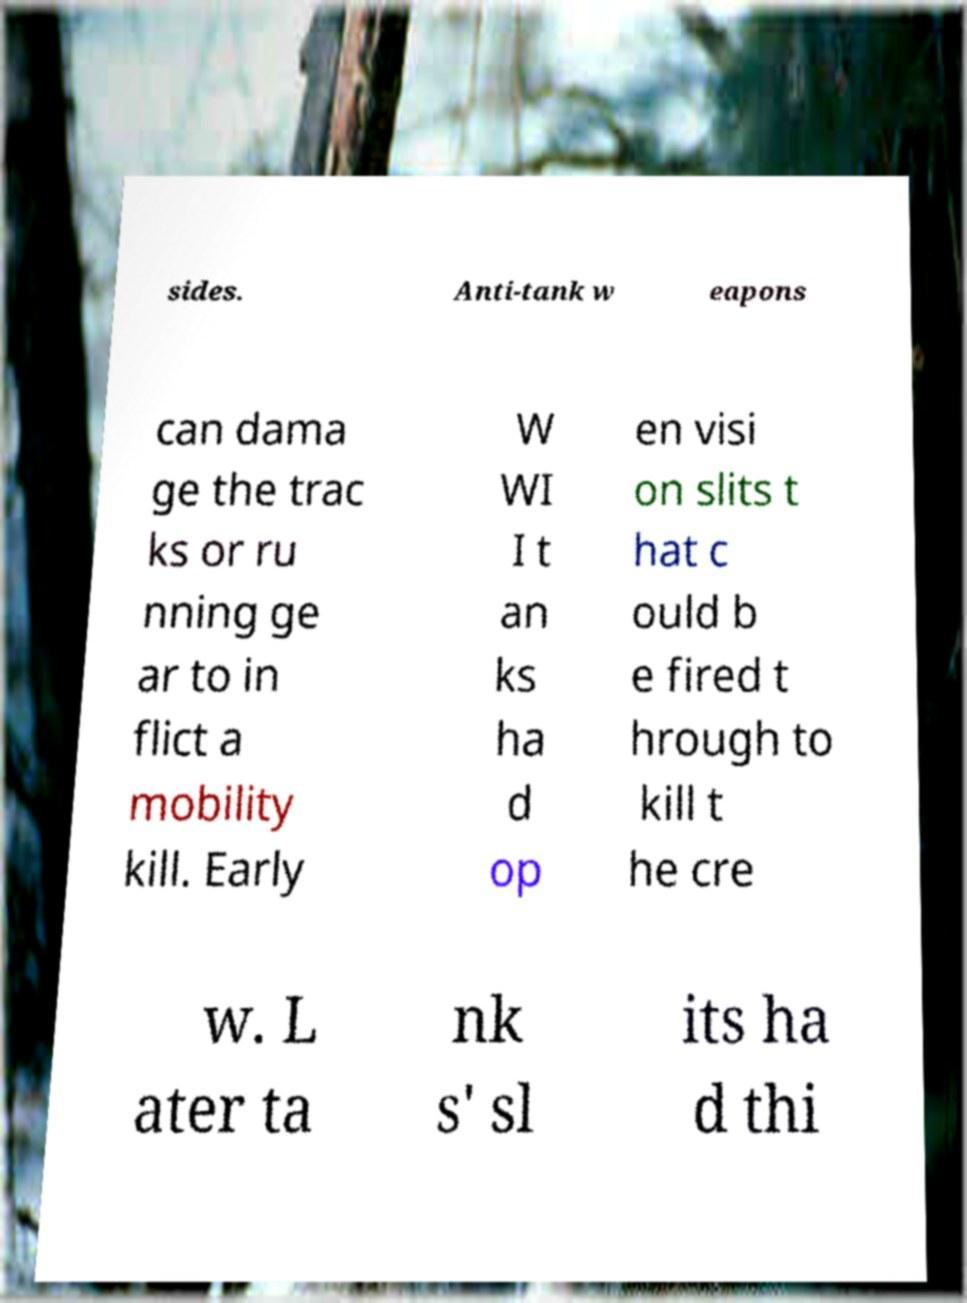I need the written content from this picture converted into text. Can you do that? sides. Anti-tank w eapons can dama ge the trac ks or ru nning ge ar to in flict a mobility kill. Early W WI I t an ks ha d op en visi on slits t hat c ould b e fired t hrough to kill t he cre w. L ater ta nk s' sl its ha d thi 